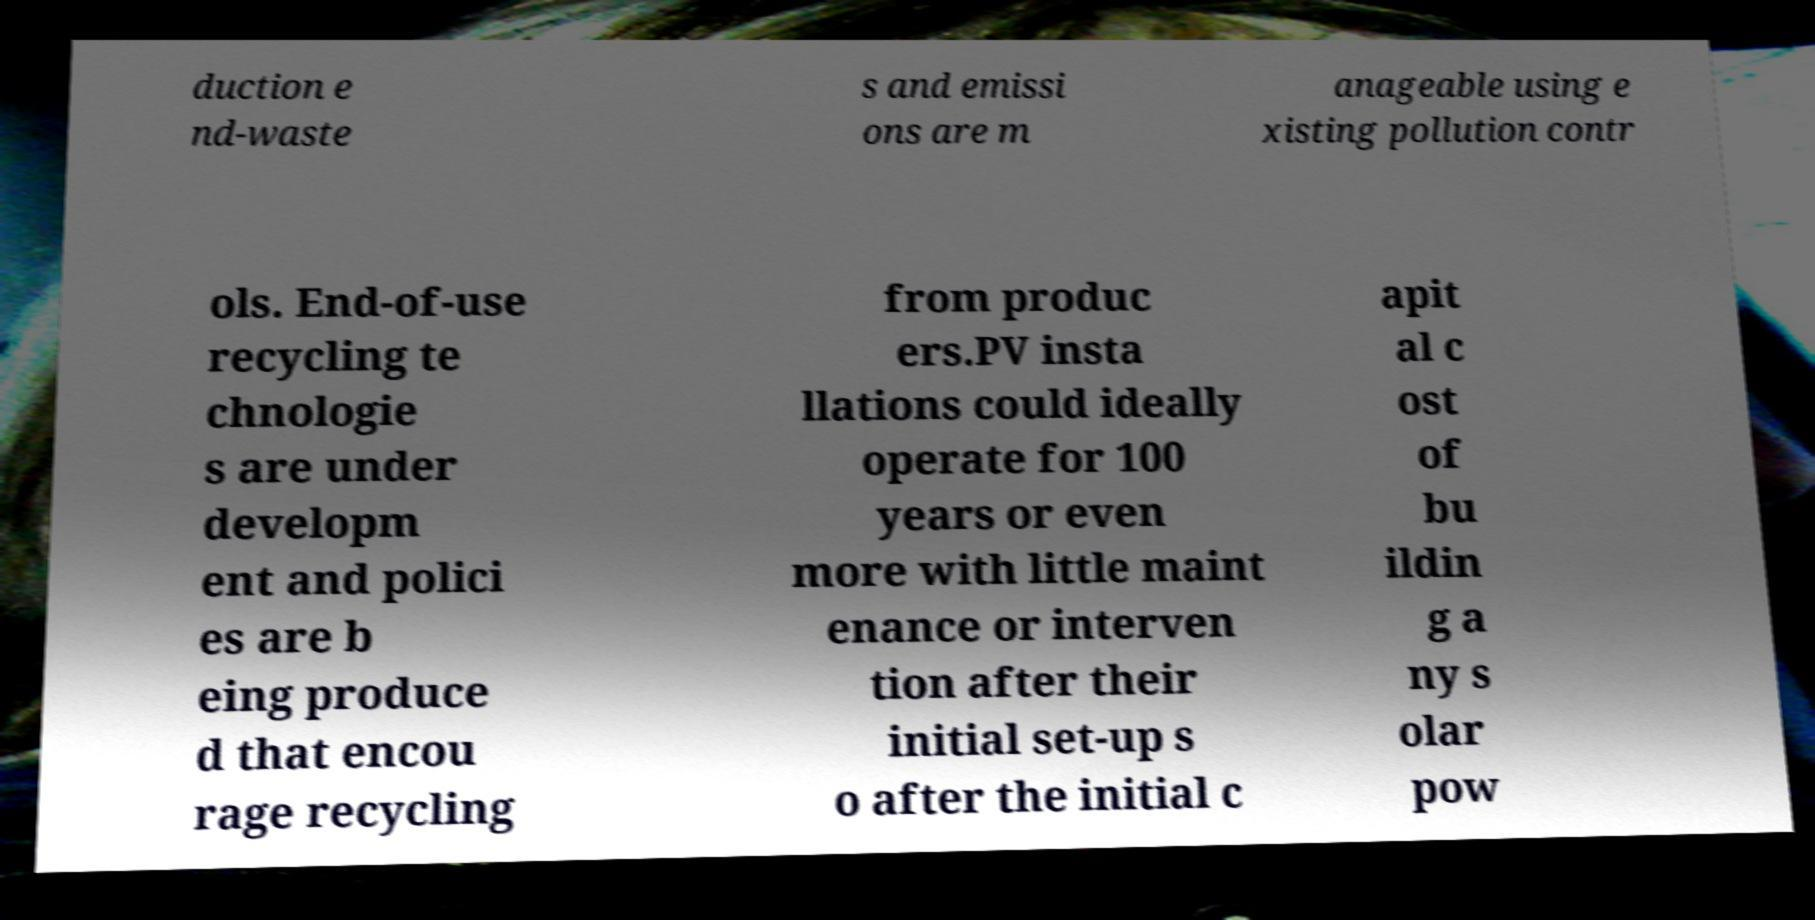What messages or text are displayed in this image? I need them in a readable, typed format. duction e nd-waste s and emissi ons are m anageable using e xisting pollution contr ols. End-of-use recycling te chnologie s are under developm ent and polici es are b eing produce d that encou rage recycling from produc ers.PV insta llations could ideally operate for 100 years or even more with little maint enance or interven tion after their initial set-up s o after the initial c apit al c ost of bu ildin g a ny s olar pow 